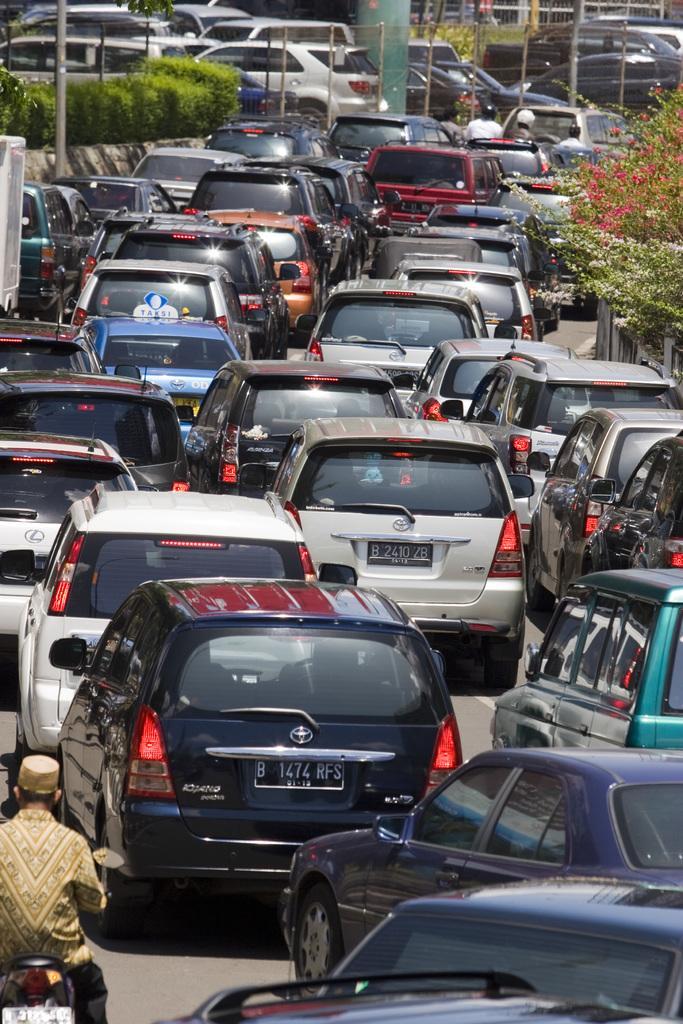Can you describe this image briefly? The picture is taken outside a city on the road there are cars. On the right there are trees and plants. In the background there are buildings, poles and trees. On the left there are trees, dustbin, pole and plants. 